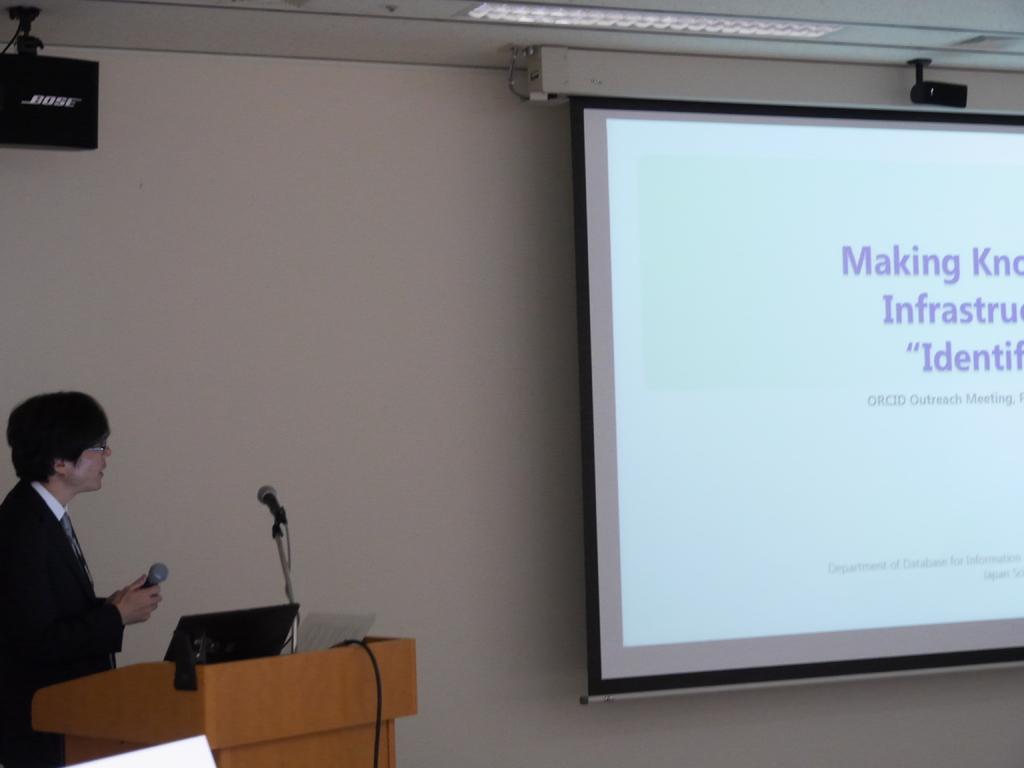Can you describe this image briefly? In this image I can see the person standing in-front of the podium. On the podium I can see the laptop and the person holding the mic. In the background I can see the screen, black color object and the wall. 